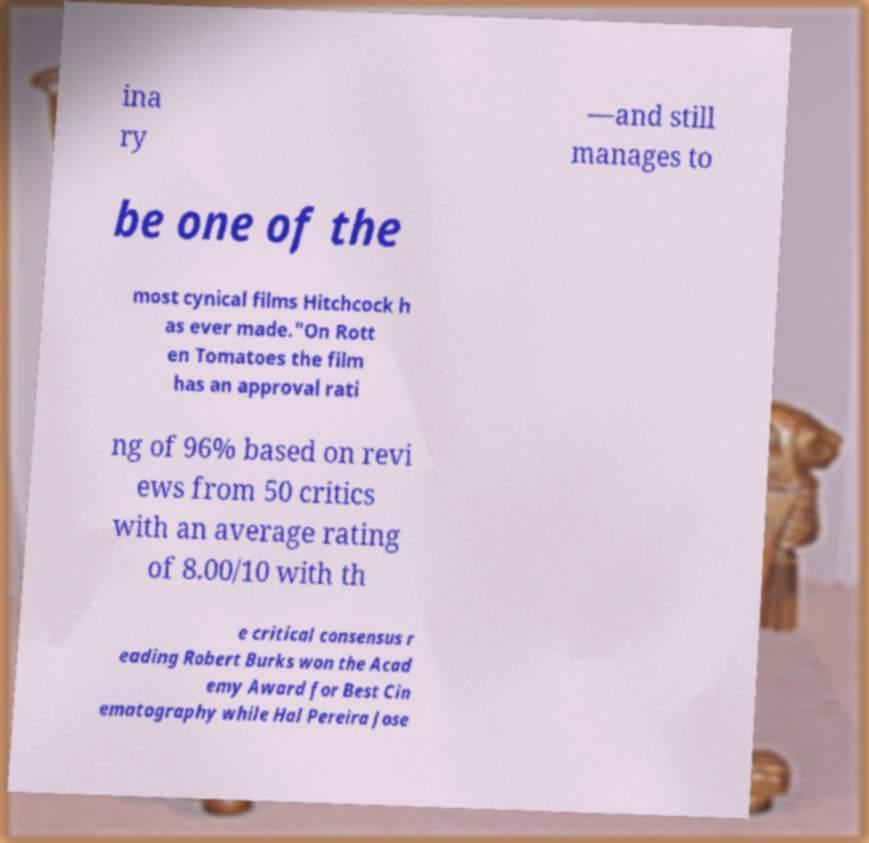Can you accurately transcribe the text from the provided image for me? ina ry —and still manages to be one of the most cynical films Hitchcock h as ever made."On Rott en Tomatoes the film has an approval rati ng of 96% based on revi ews from 50 critics with an average rating of 8.00/10 with th e critical consensus r eading Robert Burks won the Acad emy Award for Best Cin ematography while Hal Pereira Jose 